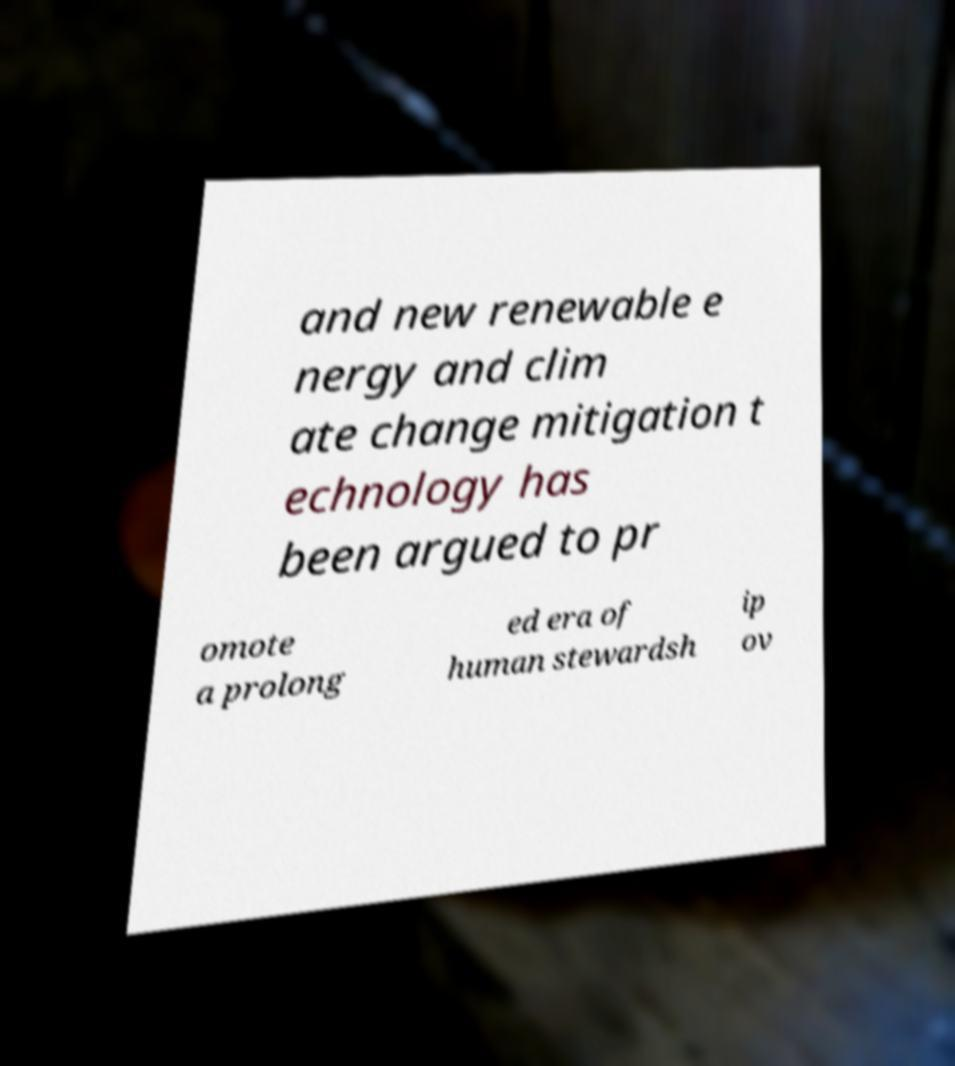Could you assist in decoding the text presented in this image and type it out clearly? and new renewable e nergy and clim ate change mitigation t echnology has been argued to pr omote a prolong ed era of human stewardsh ip ov 